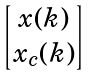Convert formula to latex. <formula><loc_0><loc_0><loc_500><loc_500>\begin{bmatrix} x ( k ) \\ x _ { c } ( k ) \end{bmatrix}</formula> 